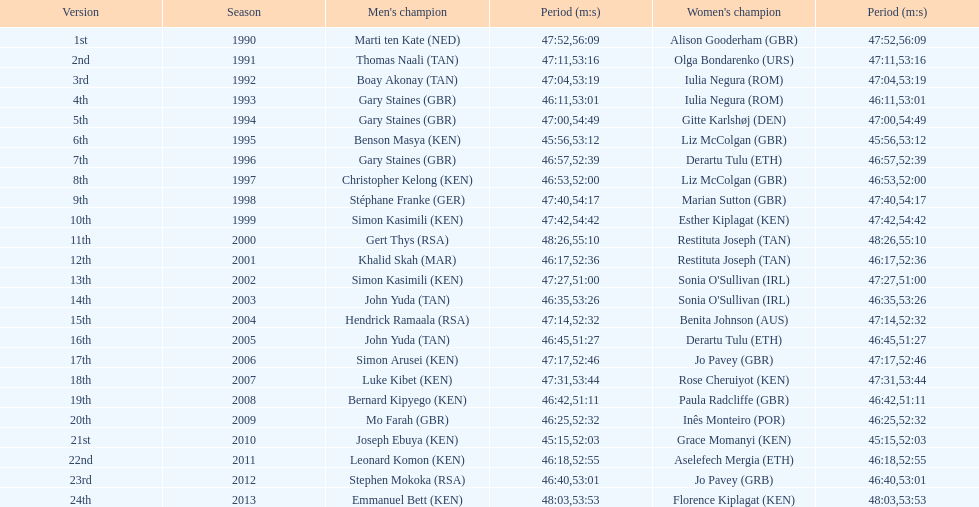Who is the male winner listed before gert thys? Simon Kasimili. 